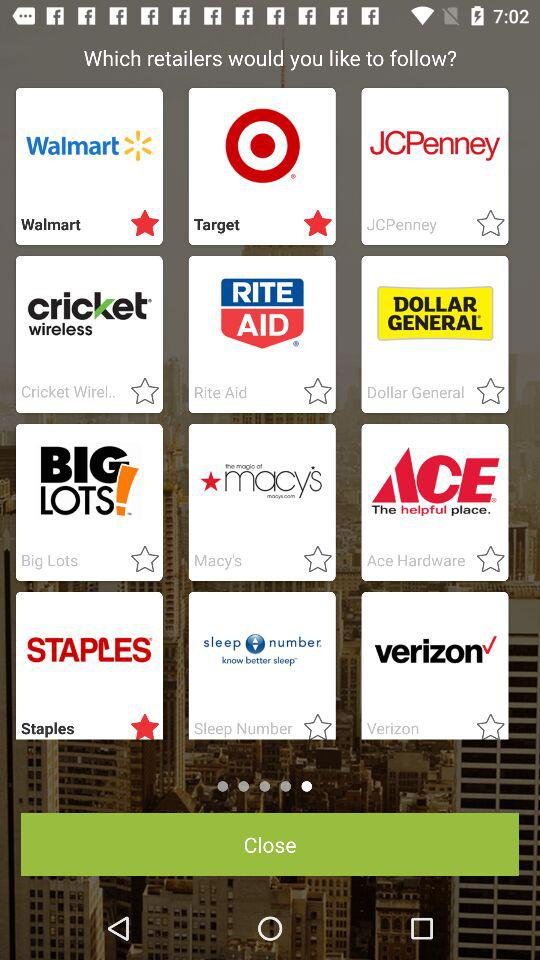Which retailers are starred among all? The starred retailers are "Walmart", "Target" and "Staples". 